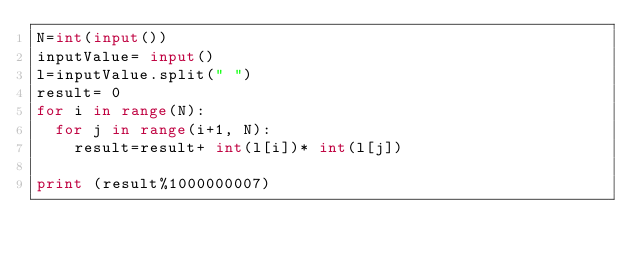Convert code to text. <code><loc_0><loc_0><loc_500><loc_500><_Python_>N=int(input())
inputValue= input()
l=inputValue.split(" ")
result= 0
for i in range(N):
	for j in range(i+1, N):
		result=result+ int(l[i])* int(l[j])
 
print (result%1000000007)</code> 